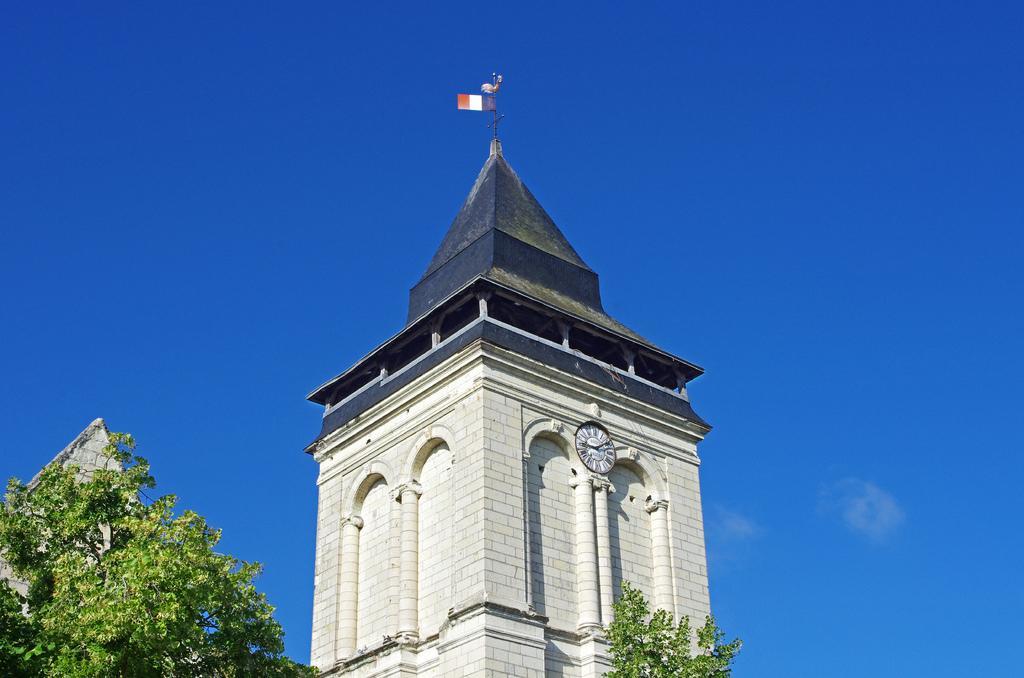Describe this image in one or two sentences. We can see tower and clock on the wall. Top of the tower we can see flag with pole and we can see trees. In the background we can see sky in blue color. 